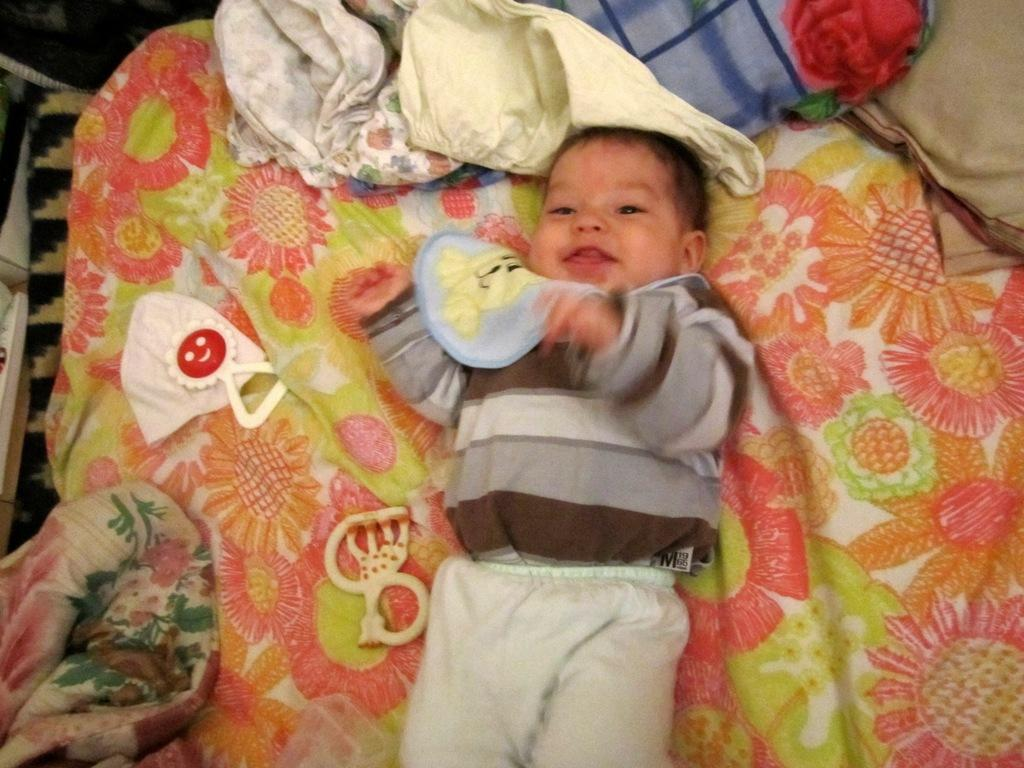What is the main subject of the image? There is a baby lying on the bed. What can be seen near the baby? There are toys, pillows, and clothes beside the baby. How many eyes can be seen on the baby in the image? The image does not show the baby's eyes, so it is not possible to determine the number of eyes. 